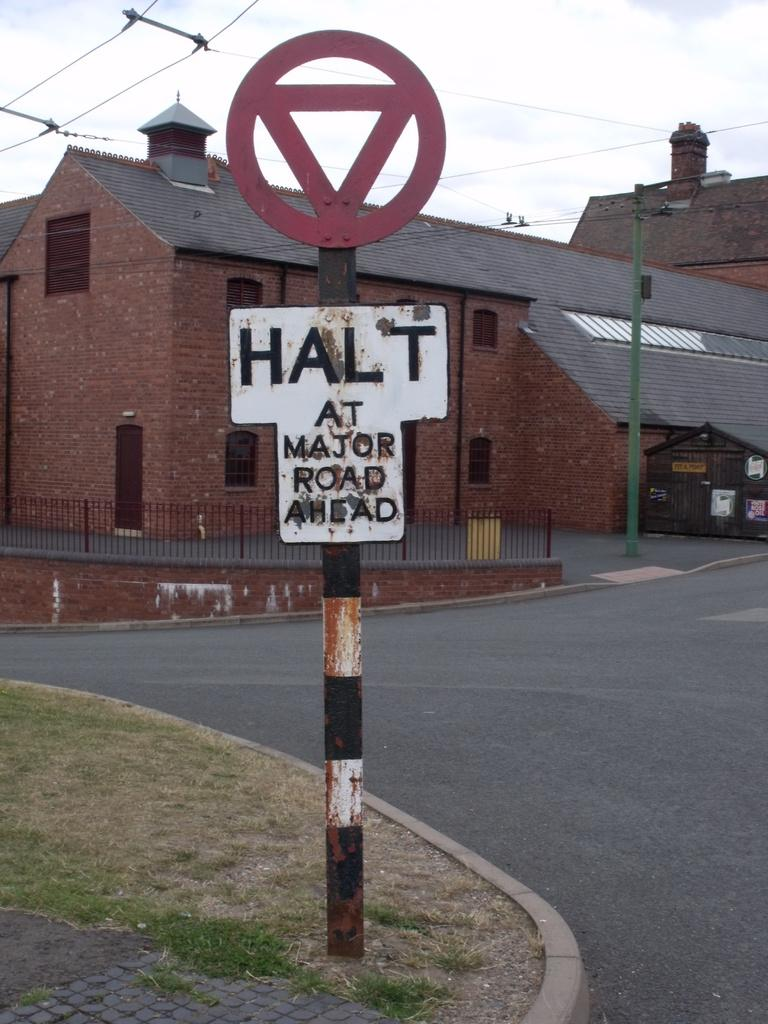Provide a one-sentence caption for the provided image. A white and black sign states Halt at major road ahead. 